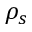Convert formula to latex. <formula><loc_0><loc_0><loc_500><loc_500>\rho _ { s }</formula> 